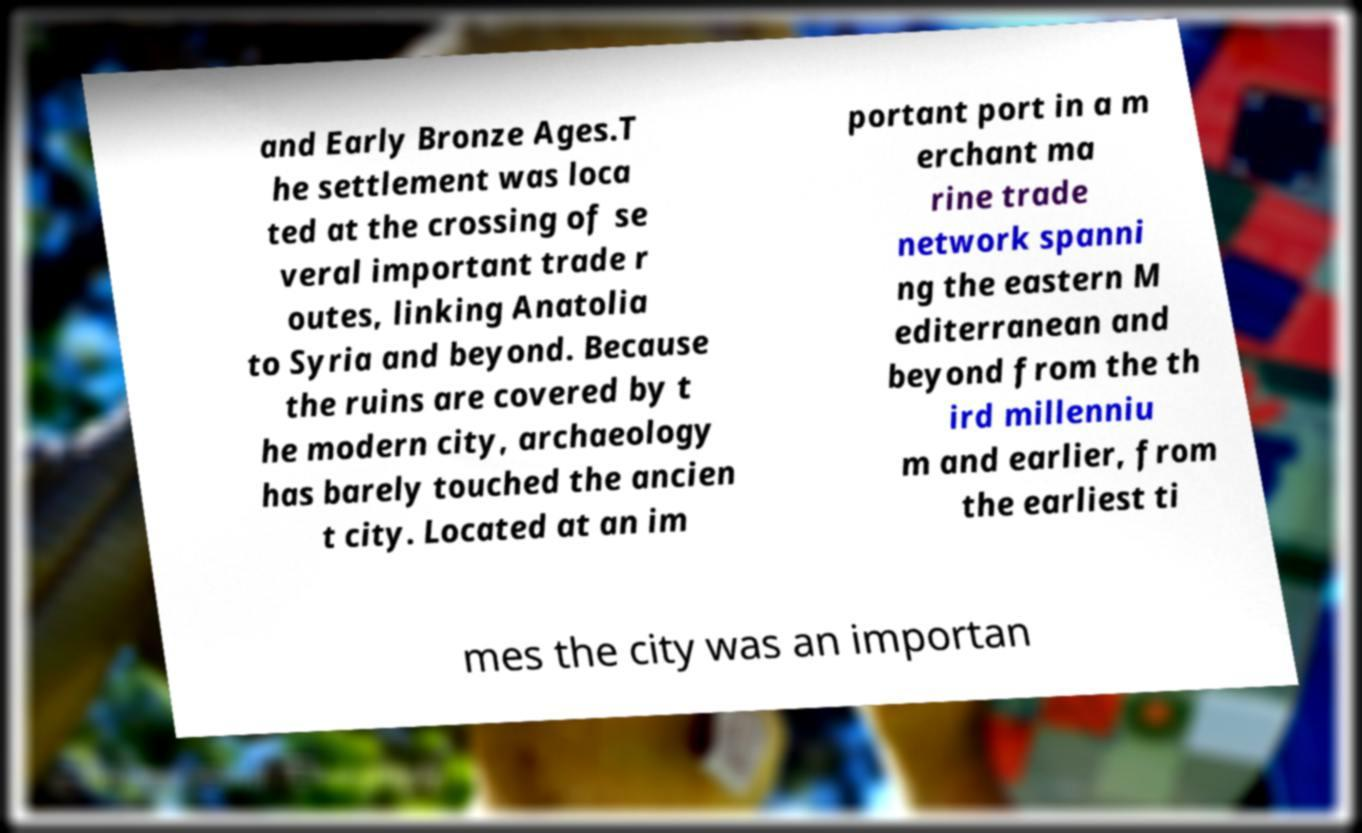There's text embedded in this image that I need extracted. Can you transcribe it verbatim? and Early Bronze Ages.T he settlement was loca ted at the crossing of se veral important trade r outes, linking Anatolia to Syria and beyond. Because the ruins are covered by t he modern city, archaeology has barely touched the ancien t city. Located at an im portant port in a m erchant ma rine trade network spanni ng the eastern M editerranean and beyond from the th ird millenniu m and earlier, from the earliest ti mes the city was an importan 